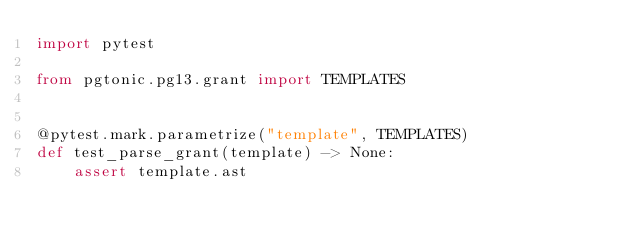Convert code to text. <code><loc_0><loc_0><loc_500><loc_500><_Python_>import pytest

from pgtonic.pg13.grant import TEMPLATES


@pytest.mark.parametrize("template", TEMPLATES)
def test_parse_grant(template) -> None:
    assert template.ast
</code> 